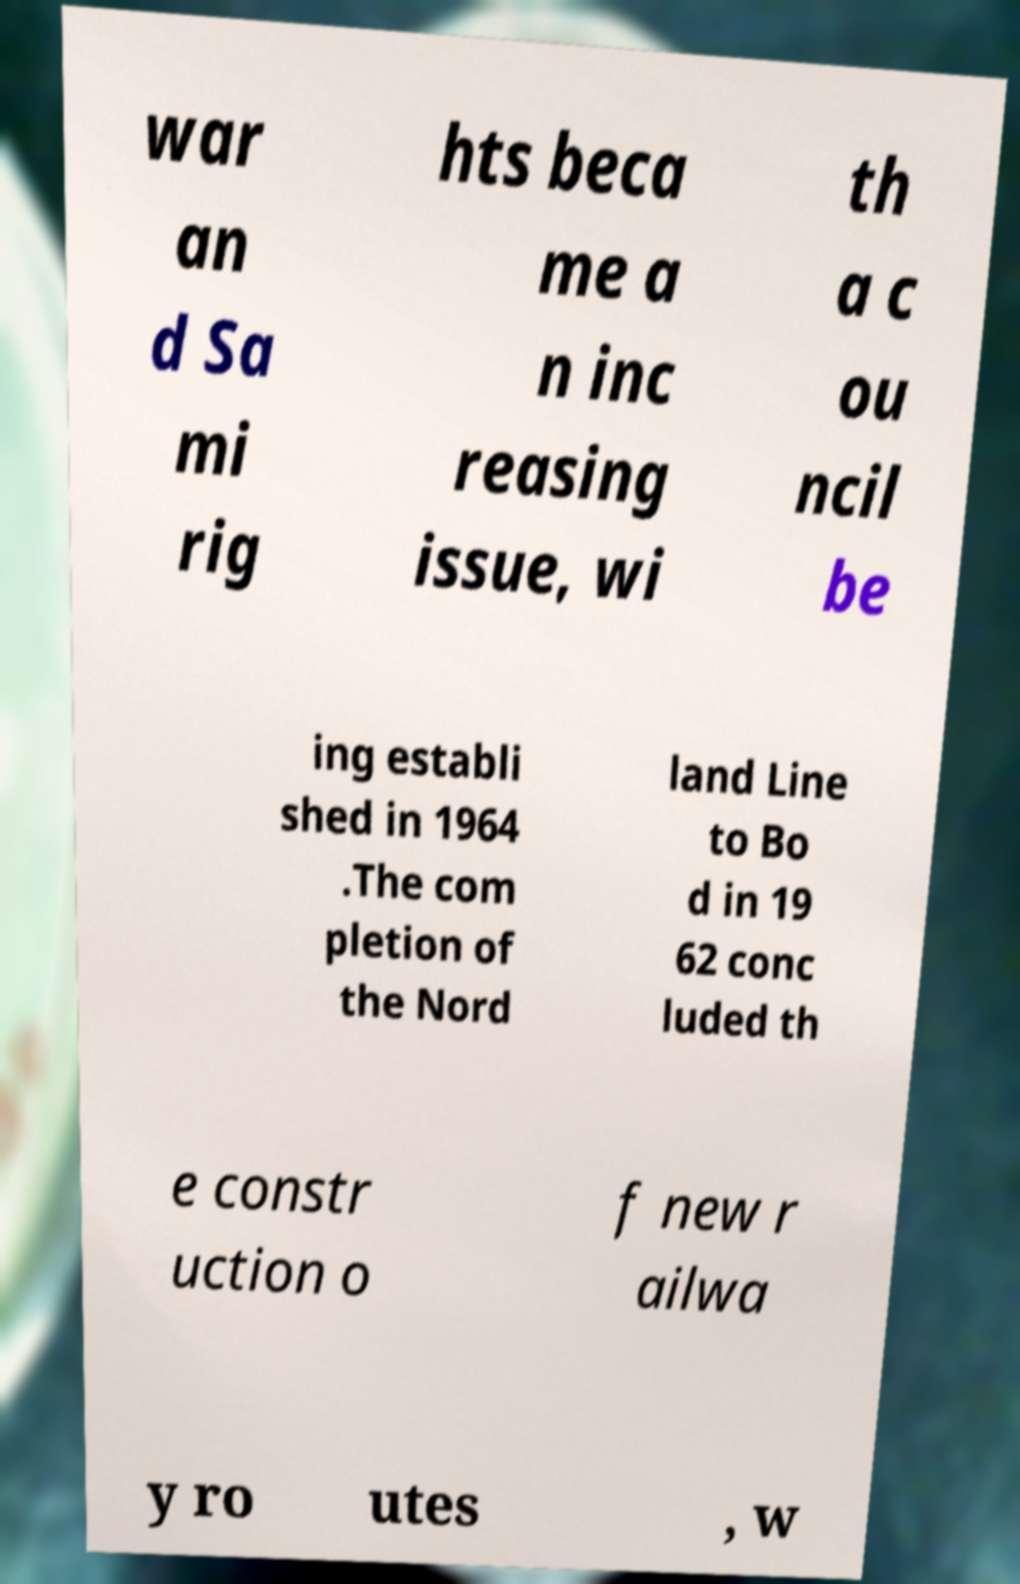There's text embedded in this image that I need extracted. Can you transcribe it verbatim? war an d Sa mi rig hts beca me a n inc reasing issue, wi th a c ou ncil be ing establi shed in 1964 .The com pletion of the Nord land Line to Bo d in 19 62 conc luded th e constr uction o f new r ailwa y ro utes , w 